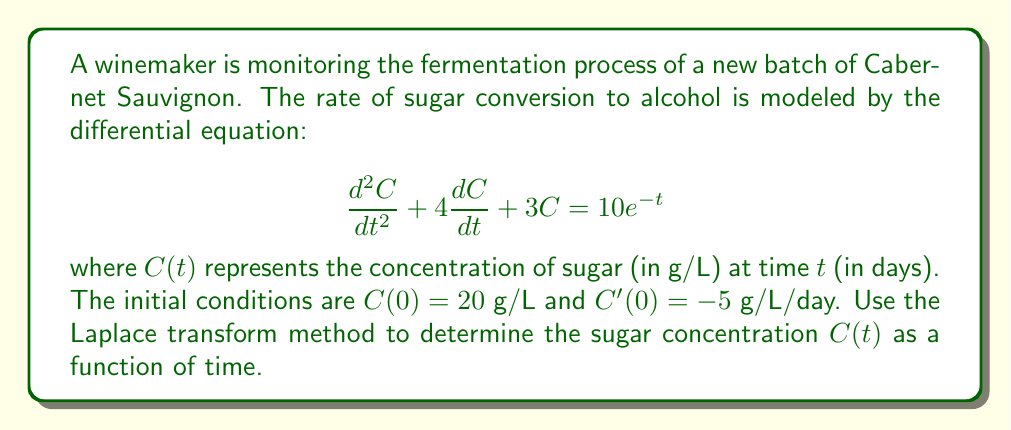Teach me how to tackle this problem. Let's solve this problem step by step using the Laplace transform method:

1) First, we take the Laplace transform of both sides of the differential equation:

   $\mathcal{L}\{d^2C/dt^2 + 4dC/dt + 3C\} = \mathcal{L}\{10e^{-t}\}$

2) Using the properties of Laplace transforms:

   $s^2C(s) - sC(0) - C'(0) + 4[sC(s) - C(0)] + 3C(s) = 10/(s+1)$

3) Substituting the initial conditions $C(0) = 20$ and $C'(0) = -5$:

   $s^2C(s) - 20s + 5 + 4sC(s) - 80 + 3C(s) = 10/(s+1)$

4) Simplifying:

   $(s^2 + 4s + 3)C(s) = 10/(s+1) + 20s + 75$

5) Solving for $C(s)$:

   $C(s) = \frac{10}{(s+1)(s^2+4s+3)} + \frac{20s+75}{s^2+4s+3}$

6) The denominator $s^2+4s+3$ can be factored as $(s+1)(s+3)$. We can now use partial fraction decomposition:

   $C(s) = \frac{A}{s+1} + \frac{B}{s+3} + \frac{10}{(s+1)^2} + \frac{D}{s+3}$

7) Solving for the constants:

   $A = 15$, $B = 5$, $D = -5$

8) Therefore:

   $C(s) = \frac{15}{s+1} + \frac{5}{s+3} + \frac{10}{(s+1)^2} - \frac{5}{s+3}$

9) Taking the inverse Laplace transform:

   $C(t) = 15e^{-t} + 5e^{-3t} + 10te^{-t} - 5e^{-3t}$

10) Simplifying:

    $C(t) = (15 + 10t)e^{-t}$

This is the final expression for the sugar concentration as a function of time.
Answer: $C(t) = (15 + 10t)e^{-t}$ g/L 